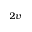<formula> <loc_0><loc_0><loc_500><loc_500>_ { 2 v }</formula> 